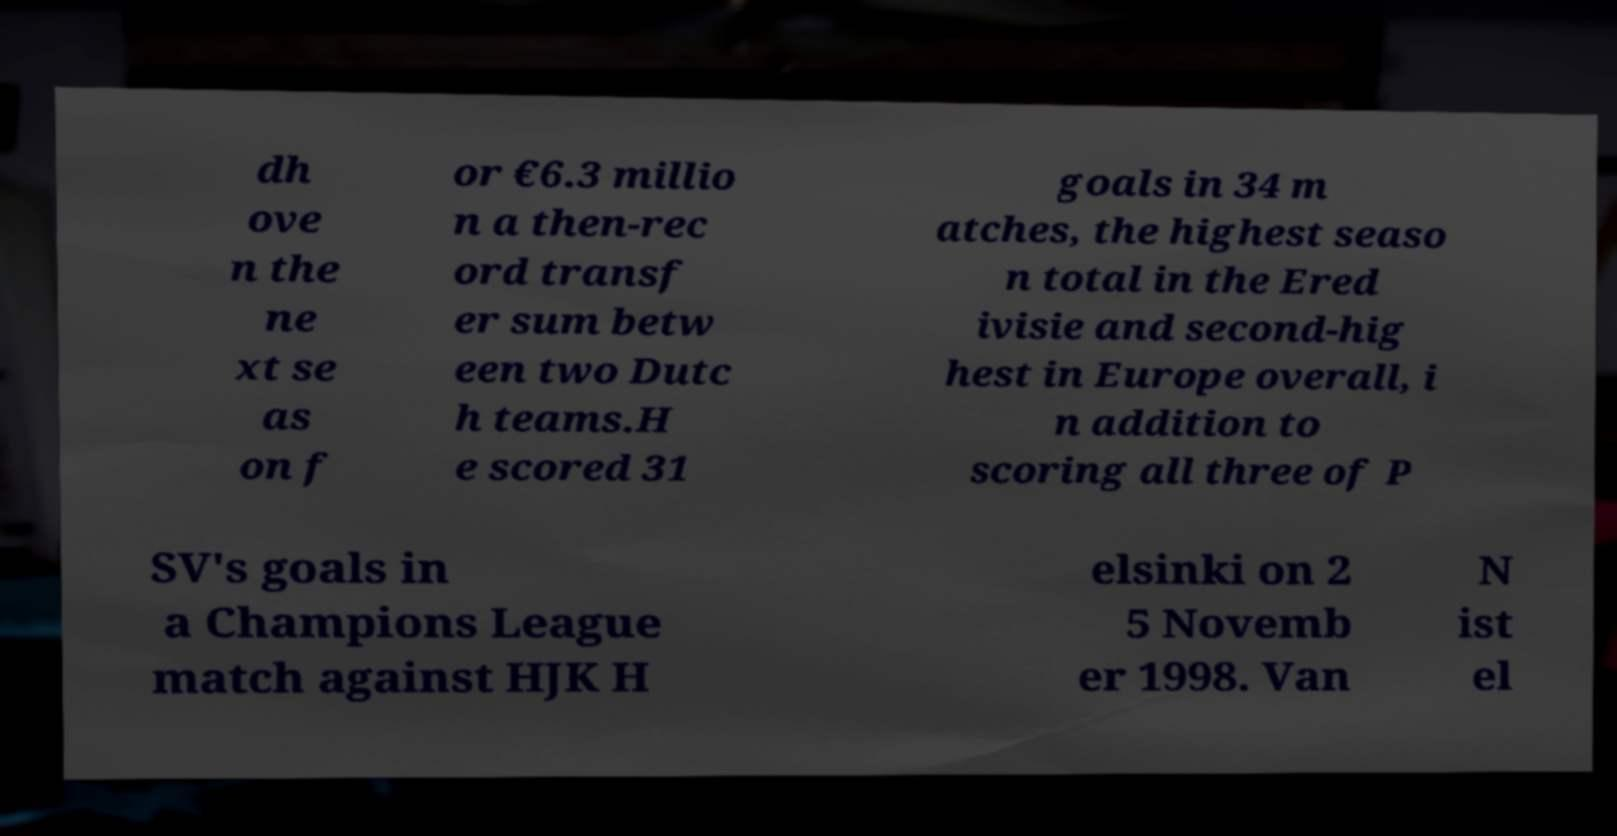For documentation purposes, I need the text within this image transcribed. Could you provide that? dh ove n the ne xt se as on f or €6.3 millio n a then-rec ord transf er sum betw een two Dutc h teams.H e scored 31 goals in 34 m atches, the highest seaso n total in the Ered ivisie and second-hig hest in Europe overall, i n addition to scoring all three of P SV's goals in a Champions League match against HJK H elsinki on 2 5 Novemb er 1998. Van N ist el 